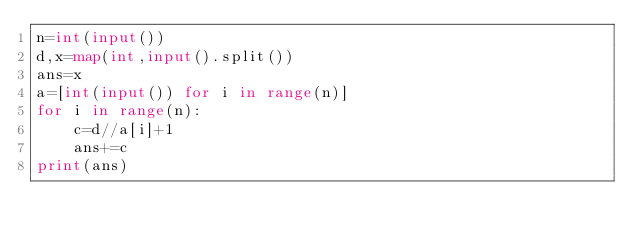<code> <loc_0><loc_0><loc_500><loc_500><_Python_>n=int(input())
d,x=map(int,input().split())
ans=x
a=[int(input()) for i in range(n)]
for i in range(n):
    c=d//a[i]+1
    ans+=c
print(ans)</code> 